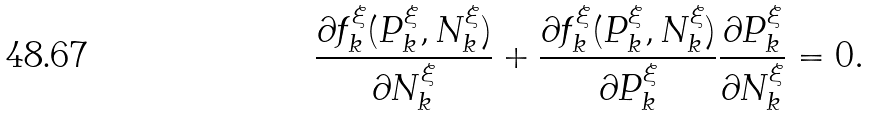<formula> <loc_0><loc_0><loc_500><loc_500>\frac { \partial f _ { k } ^ { \xi } ( P _ { k } ^ { \xi } , N _ { k } ^ { \xi } ) } { \partial N _ { k } ^ { \xi } } + \frac { \partial f _ { k } ^ { \xi } ( P _ { k } ^ { \xi } , N _ { k } ^ { \xi } ) } { \partial P _ { k } ^ { \xi } } \frac { \partial P _ { k } ^ { \xi } } { \partial N _ { k } ^ { \xi } } = 0 .</formula> 